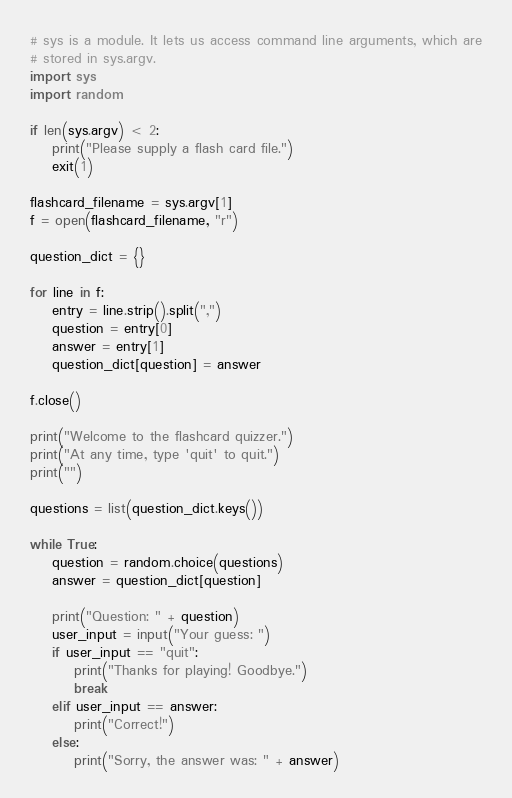Convert code to text. <code><loc_0><loc_0><loc_500><loc_500><_Python_># sys is a module. It lets us access command line arguments, which are
# stored in sys.argv.
import sys
import random

if len(sys.argv) < 2:
    print("Please supply a flash card file.")
    exit(1)

flashcard_filename = sys.argv[1]
f = open(flashcard_filename, "r")

question_dict = {}

for line in f:
    entry = line.strip().split(",")
    question = entry[0]
    answer = entry[1]
    question_dict[question] = answer

f.close()

print("Welcome to the flashcard quizzer.")
print("At any time, type 'quit' to quit.")
print("")

questions = list(question_dict.keys())

while True:
    question = random.choice(questions)
    answer = question_dict[question]

    print("Question: " + question)
    user_input = input("Your guess: ")
    if user_input == "quit":
        print("Thanks for playing! Goodbye.")
        break
    elif user_input == answer:
        print("Correct!")
    else:
        print("Sorry, the answer was: " + answer)

</code> 